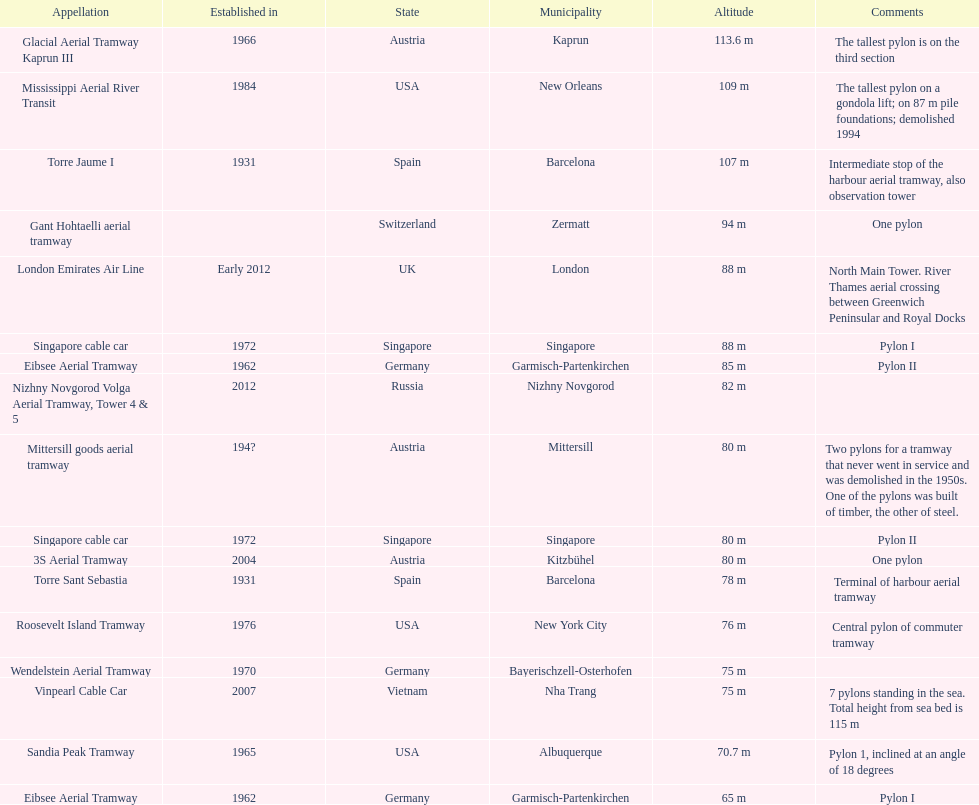List two pylons that are at most, 80 m in height. Mittersill goods aerial tramway, Singapore cable car. 